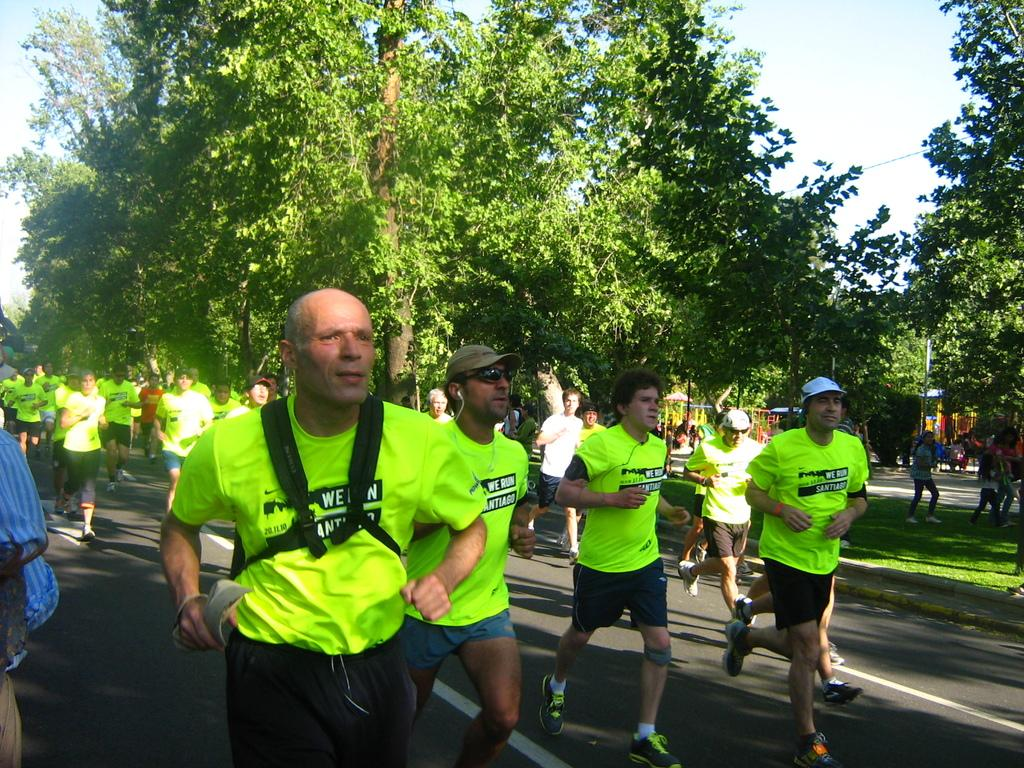What can be seen in the background of the image? The sky is visible in the background of the image. What is the weather like on this day? It appears to be a sunny day. What type of vegetation is present in the image? There are trees in the image. What are the people wearing in the image? People are wearing t-shirts. What activity are the people engaged in? People are running on the road. How many patches can be seen on the frogs in the image? There are no frogs present in the image, so there are no patches to count. 